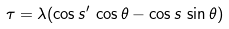<formula> <loc_0><loc_0><loc_500><loc_500>\tau = \lambda ( \cos s ^ { \prime } \, \cos \theta - \cos s \, \sin \theta )</formula> 